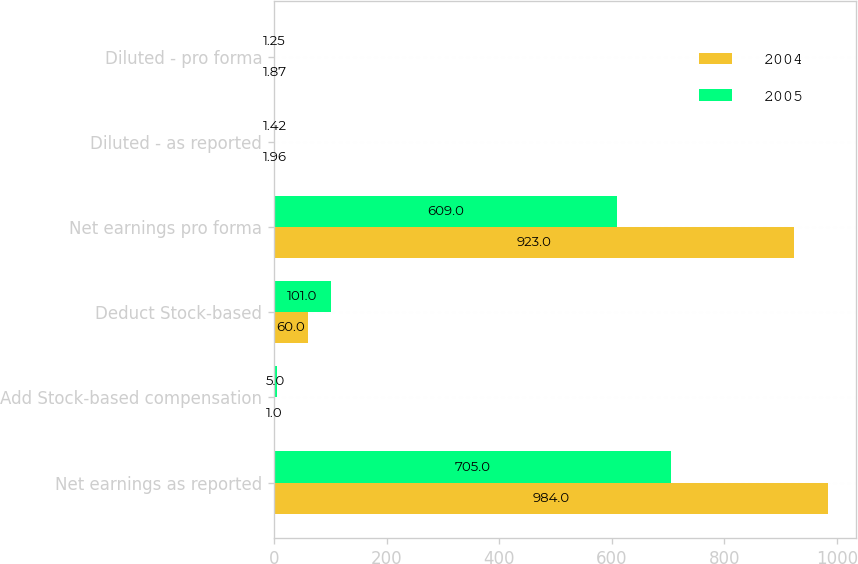Convert chart to OTSL. <chart><loc_0><loc_0><loc_500><loc_500><stacked_bar_chart><ecel><fcel>Net earnings as reported<fcel>Add Stock-based compensation<fcel>Deduct Stock-based<fcel>Net earnings pro forma<fcel>Diluted - as reported<fcel>Diluted - pro forma<nl><fcel>2004<fcel>984<fcel>1<fcel>60<fcel>923<fcel>1.96<fcel>1.87<nl><fcel>2005<fcel>705<fcel>5<fcel>101<fcel>609<fcel>1.42<fcel>1.25<nl></chart> 